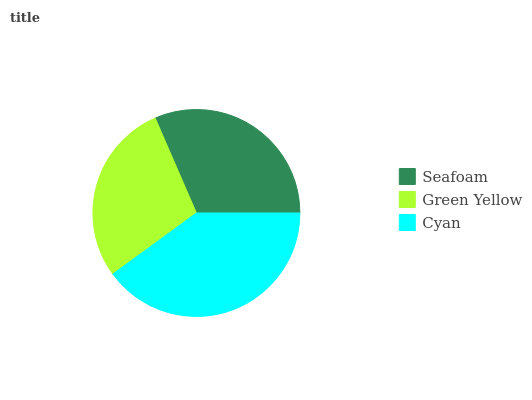Is Green Yellow the minimum?
Answer yes or no. Yes. Is Cyan the maximum?
Answer yes or no. Yes. Is Cyan the minimum?
Answer yes or no. No. Is Green Yellow the maximum?
Answer yes or no. No. Is Cyan greater than Green Yellow?
Answer yes or no. Yes. Is Green Yellow less than Cyan?
Answer yes or no. Yes. Is Green Yellow greater than Cyan?
Answer yes or no. No. Is Cyan less than Green Yellow?
Answer yes or no. No. Is Seafoam the high median?
Answer yes or no. Yes. Is Seafoam the low median?
Answer yes or no. Yes. Is Green Yellow the high median?
Answer yes or no. No. Is Green Yellow the low median?
Answer yes or no. No. 